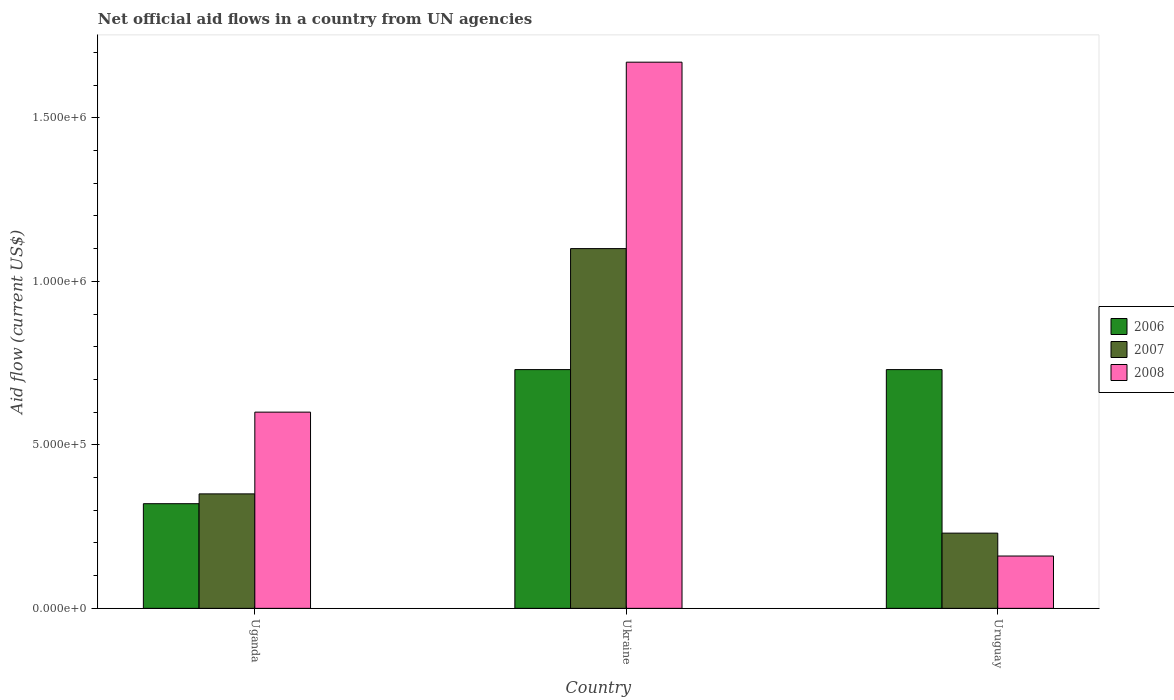How many different coloured bars are there?
Give a very brief answer. 3. Are the number of bars per tick equal to the number of legend labels?
Provide a succinct answer. Yes. Are the number of bars on each tick of the X-axis equal?
Offer a very short reply. Yes. How many bars are there on the 1st tick from the left?
Your answer should be compact. 3. How many bars are there on the 2nd tick from the right?
Your answer should be compact. 3. What is the label of the 2nd group of bars from the left?
Provide a succinct answer. Ukraine. Across all countries, what is the maximum net official aid flow in 2006?
Ensure brevity in your answer.  7.30e+05. In which country was the net official aid flow in 2008 maximum?
Give a very brief answer. Ukraine. In which country was the net official aid flow in 2006 minimum?
Your answer should be very brief. Uganda. What is the total net official aid flow in 2007 in the graph?
Your response must be concise. 1.68e+06. What is the difference between the net official aid flow in 2007 in Ukraine and the net official aid flow in 2006 in Uganda?
Your answer should be very brief. 7.80e+05. What is the average net official aid flow in 2007 per country?
Make the answer very short. 5.60e+05. What is the difference between the net official aid flow of/in 2007 and net official aid flow of/in 2006 in Ukraine?
Make the answer very short. 3.70e+05. What is the ratio of the net official aid flow in 2008 in Uganda to that in Ukraine?
Offer a terse response. 0.36. Is the net official aid flow in 2008 in Ukraine less than that in Uruguay?
Offer a very short reply. No. What is the difference between the highest and the second highest net official aid flow in 2008?
Ensure brevity in your answer.  1.51e+06. What is the difference between the highest and the lowest net official aid flow in 2007?
Your answer should be very brief. 8.70e+05. In how many countries, is the net official aid flow in 2008 greater than the average net official aid flow in 2008 taken over all countries?
Provide a short and direct response. 1. How many bars are there?
Offer a very short reply. 9. How many countries are there in the graph?
Make the answer very short. 3. Are the values on the major ticks of Y-axis written in scientific E-notation?
Give a very brief answer. Yes. Does the graph contain any zero values?
Make the answer very short. No. Does the graph contain grids?
Your answer should be compact. No. How are the legend labels stacked?
Your answer should be compact. Vertical. What is the title of the graph?
Provide a succinct answer. Net official aid flows in a country from UN agencies. What is the label or title of the X-axis?
Ensure brevity in your answer.  Country. What is the Aid flow (current US$) of 2006 in Uganda?
Your answer should be very brief. 3.20e+05. What is the Aid flow (current US$) in 2007 in Uganda?
Your answer should be very brief. 3.50e+05. What is the Aid flow (current US$) in 2006 in Ukraine?
Ensure brevity in your answer.  7.30e+05. What is the Aid flow (current US$) in 2007 in Ukraine?
Your response must be concise. 1.10e+06. What is the Aid flow (current US$) in 2008 in Ukraine?
Your response must be concise. 1.67e+06. What is the Aid flow (current US$) of 2006 in Uruguay?
Keep it short and to the point. 7.30e+05. What is the Aid flow (current US$) in 2007 in Uruguay?
Your response must be concise. 2.30e+05. What is the Aid flow (current US$) in 2008 in Uruguay?
Offer a very short reply. 1.60e+05. Across all countries, what is the maximum Aid flow (current US$) in 2006?
Keep it short and to the point. 7.30e+05. Across all countries, what is the maximum Aid flow (current US$) of 2007?
Provide a succinct answer. 1.10e+06. Across all countries, what is the maximum Aid flow (current US$) of 2008?
Ensure brevity in your answer.  1.67e+06. Across all countries, what is the minimum Aid flow (current US$) in 2006?
Your response must be concise. 3.20e+05. Across all countries, what is the minimum Aid flow (current US$) of 2008?
Provide a succinct answer. 1.60e+05. What is the total Aid flow (current US$) of 2006 in the graph?
Make the answer very short. 1.78e+06. What is the total Aid flow (current US$) in 2007 in the graph?
Offer a very short reply. 1.68e+06. What is the total Aid flow (current US$) in 2008 in the graph?
Provide a succinct answer. 2.43e+06. What is the difference between the Aid flow (current US$) in 2006 in Uganda and that in Ukraine?
Your response must be concise. -4.10e+05. What is the difference between the Aid flow (current US$) of 2007 in Uganda and that in Ukraine?
Ensure brevity in your answer.  -7.50e+05. What is the difference between the Aid flow (current US$) in 2008 in Uganda and that in Ukraine?
Keep it short and to the point. -1.07e+06. What is the difference between the Aid flow (current US$) in 2006 in Uganda and that in Uruguay?
Provide a short and direct response. -4.10e+05. What is the difference between the Aid flow (current US$) of 2007 in Uganda and that in Uruguay?
Keep it short and to the point. 1.20e+05. What is the difference between the Aid flow (current US$) of 2006 in Ukraine and that in Uruguay?
Give a very brief answer. 0. What is the difference between the Aid flow (current US$) of 2007 in Ukraine and that in Uruguay?
Your answer should be very brief. 8.70e+05. What is the difference between the Aid flow (current US$) of 2008 in Ukraine and that in Uruguay?
Your answer should be very brief. 1.51e+06. What is the difference between the Aid flow (current US$) of 2006 in Uganda and the Aid flow (current US$) of 2007 in Ukraine?
Ensure brevity in your answer.  -7.80e+05. What is the difference between the Aid flow (current US$) in 2006 in Uganda and the Aid flow (current US$) in 2008 in Ukraine?
Ensure brevity in your answer.  -1.35e+06. What is the difference between the Aid flow (current US$) of 2007 in Uganda and the Aid flow (current US$) of 2008 in Ukraine?
Your response must be concise. -1.32e+06. What is the difference between the Aid flow (current US$) of 2006 in Uganda and the Aid flow (current US$) of 2008 in Uruguay?
Offer a terse response. 1.60e+05. What is the difference between the Aid flow (current US$) of 2006 in Ukraine and the Aid flow (current US$) of 2007 in Uruguay?
Ensure brevity in your answer.  5.00e+05. What is the difference between the Aid flow (current US$) in 2006 in Ukraine and the Aid flow (current US$) in 2008 in Uruguay?
Your response must be concise. 5.70e+05. What is the difference between the Aid flow (current US$) in 2007 in Ukraine and the Aid flow (current US$) in 2008 in Uruguay?
Offer a terse response. 9.40e+05. What is the average Aid flow (current US$) in 2006 per country?
Give a very brief answer. 5.93e+05. What is the average Aid flow (current US$) in 2007 per country?
Your response must be concise. 5.60e+05. What is the average Aid flow (current US$) in 2008 per country?
Make the answer very short. 8.10e+05. What is the difference between the Aid flow (current US$) in 2006 and Aid flow (current US$) in 2007 in Uganda?
Ensure brevity in your answer.  -3.00e+04. What is the difference between the Aid flow (current US$) in 2006 and Aid flow (current US$) in 2008 in Uganda?
Your answer should be compact. -2.80e+05. What is the difference between the Aid flow (current US$) in 2006 and Aid flow (current US$) in 2007 in Ukraine?
Your answer should be compact. -3.70e+05. What is the difference between the Aid flow (current US$) in 2006 and Aid flow (current US$) in 2008 in Ukraine?
Keep it short and to the point. -9.40e+05. What is the difference between the Aid flow (current US$) of 2007 and Aid flow (current US$) of 2008 in Ukraine?
Your answer should be very brief. -5.70e+05. What is the difference between the Aid flow (current US$) of 2006 and Aid flow (current US$) of 2008 in Uruguay?
Ensure brevity in your answer.  5.70e+05. What is the ratio of the Aid flow (current US$) of 2006 in Uganda to that in Ukraine?
Your response must be concise. 0.44. What is the ratio of the Aid flow (current US$) in 2007 in Uganda to that in Ukraine?
Give a very brief answer. 0.32. What is the ratio of the Aid flow (current US$) of 2008 in Uganda to that in Ukraine?
Your answer should be very brief. 0.36. What is the ratio of the Aid flow (current US$) of 2006 in Uganda to that in Uruguay?
Provide a succinct answer. 0.44. What is the ratio of the Aid flow (current US$) of 2007 in Uganda to that in Uruguay?
Make the answer very short. 1.52. What is the ratio of the Aid flow (current US$) of 2008 in Uganda to that in Uruguay?
Provide a short and direct response. 3.75. What is the ratio of the Aid flow (current US$) in 2006 in Ukraine to that in Uruguay?
Your response must be concise. 1. What is the ratio of the Aid flow (current US$) in 2007 in Ukraine to that in Uruguay?
Your response must be concise. 4.78. What is the ratio of the Aid flow (current US$) in 2008 in Ukraine to that in Uruguay?
Offer a very short reply. 10.44. What is the difference between the highest and the second highest Aid flow (current US$) in 2006?
Your answer should be very brief. 0. What is the difference between the highest and the second highest Aid flow (current US$) in 2007?
Your answer should be compact. 7.50e+05. What is the difference between the highest and the second highest Aid flow (current US$) of 2008?
Your answer should be compact. 1.07e+06. What is the difference between the highest and the lowest Aid flow (current US$) of 2007?
Keep it short and to the point. 8.70e+05. What is the difference between the highest and the lowest Aid flow (current US$) of 2008?
Give a very brief answer. 1.51e+06. 